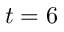Convert formula to latex. <formula><loc_0><loc_0><loc_500><loc_500>t = 6</formula> 